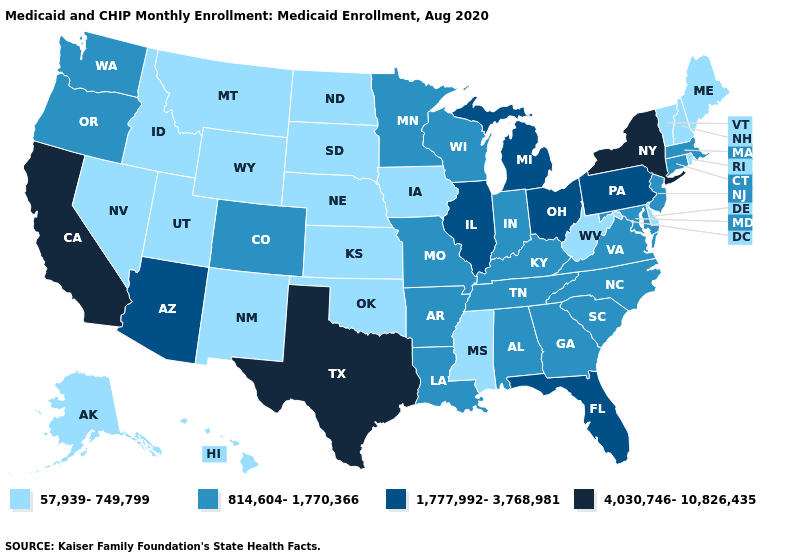Does Michigan have a higher value than Texas?
Keep it brief. No. How many symbols are there in the legend?
Short answer required. 4. What is the value of West Virginia?
Give a very brief answer. 57,939-749,799. What is the lowest value in states that border Michigan?
Write a very short answer. 814,604-1,770,366. What is the value of Florida?
Quick response, please. 1,777,992-3,768,981. Among the states that border Tennessee , does Mississippi have the lowest value?
Concise answer only. Yes. What is the lowest value in the MidWest?
Keep it brief. 57,939-749,799. Is the legend a continuous bar?
Keep it brief. No. What is the lowest value in the West?
Concise answer only. 57,939-749,799. What is the lowest value in the Northeast?
Write a very short answer. 57,939-749,799. What is the lowest value in the USA?
Quick response, please. 57,939-749,799. What is the value of New Mexico?
Concise answer only. 57,939-749,799. Name the states that have a value in the range 57,939-749,799?
Short answer required. Alaska, Delaware, Hawaii, Idaho, Iowa, Kansas, Maine, Mississippi, Montana, Nebraska, Nevada, New Hampshire, New Mexico, North Dakota, Oklahoma, Rhode Island, South Dakota, Utah, Vermont, West Virginia, Wyoming. Does Maine have the same value as Montana?
Write a very short answer. Yes. Does Alabama have the lowest value in the South?
Be succinct. No. 